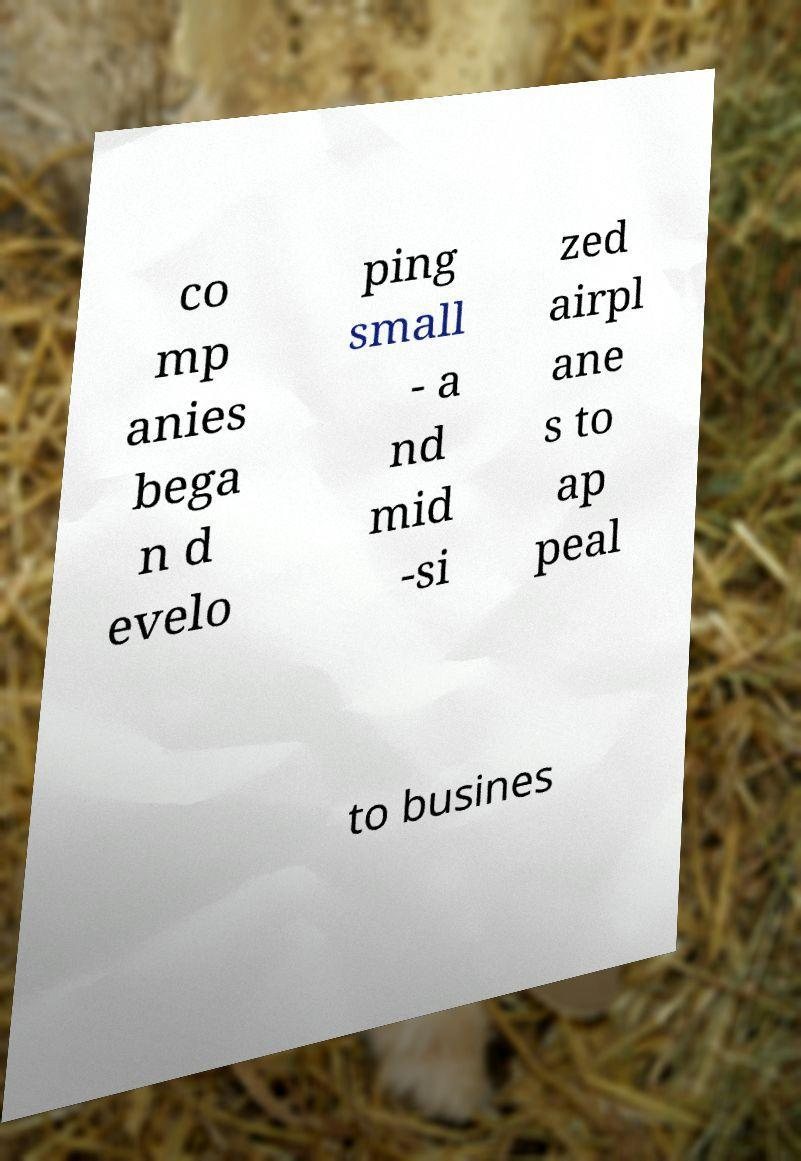Can you read and provide the text displayed in the image?This photo seems to have some interesting text. Can you extract and type it out for me? co mp anies bega n d evelo ping small - a nd mid -si zed airpl ane s to ap peal to busines 